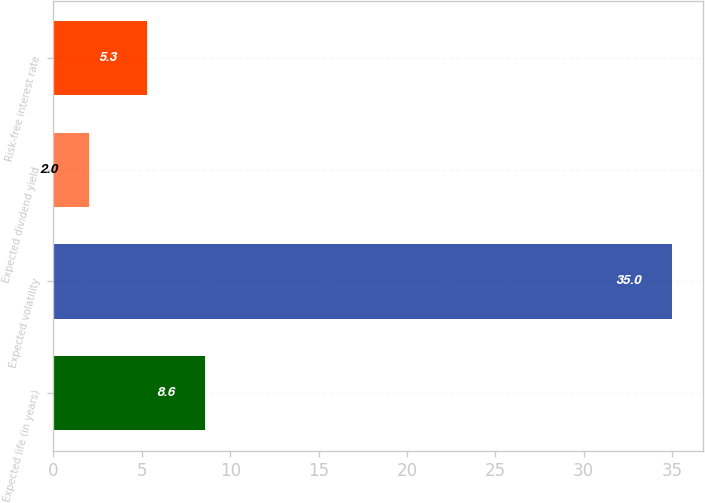Convert chart. <chart><loc_0><loc_0><loc_500><loc_500><bar_chart><fcel>Expected life (in years)<fcel>Expected volatility<fcel>Expected dividend yield<fcel>Risk-free interest rate<nl><fcel>8.6<fcel>35<fcel>2<fcel>5.3<nl></chart> 